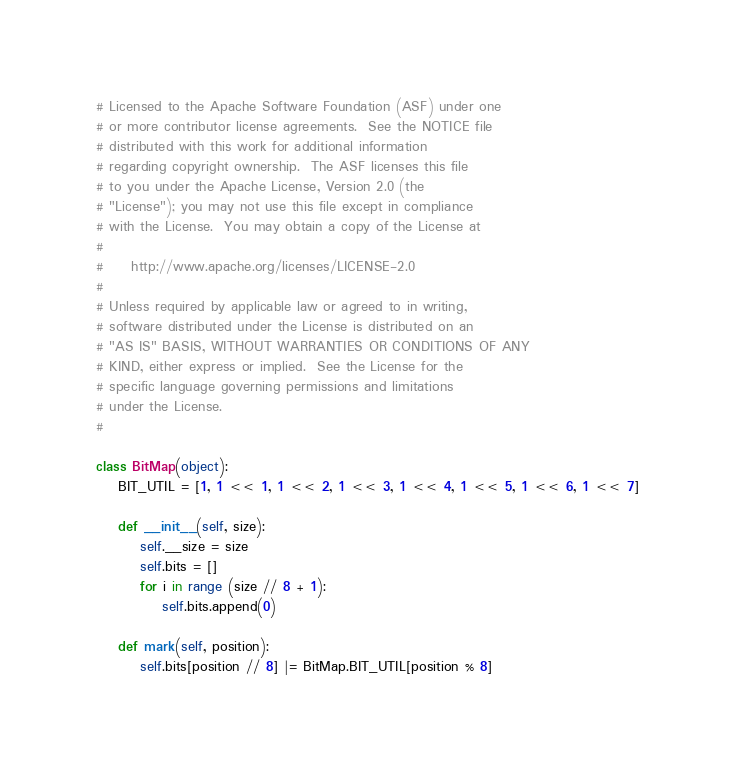<code> <loc_0><loc_0><loc_500><loc_500><_Python_># Licensed to the Apache Software Foundation (ASF) under one
# or more contributor license agreements.  See the NOTICE file
# distributed with this work for additional information
# regarding copyright ownership.  The ASF licenses this file
# to you under the Apache License, Version 2.0 (the
# "License"); you may not use this file except in compliance
# with the License.  You may obtain a copy of the License at
#
#     http://www.apache.org/licenses/LICENSE-2.0
#
# Unless required by applicable law or agreed to in writing,
# software distributed under the License is distributed on an
# "AS IS" BASIS, WITHOUT WARRANTIES OR CONDITIONS OF ANY
# KIND, either express or implied.  See the License for the
# specific language governing permissions and limitations
# under the License.
#

class BitMap(object):
    BIT_UTIL = [1, 1 << 1, 1 << 2, 1 << 3, 1 << 4, 1 << 5, 1 << 6, 1 << 7]

    def __init__(self, size):
        self.__size = size
        self.bits = []
        for i in range (size // 8 + 1):
            self.bits.append(0)

    def mark(self, position):
        self.bits[position // 8] |= BitMap.BIT_UTIL[position % 8]
</code> 